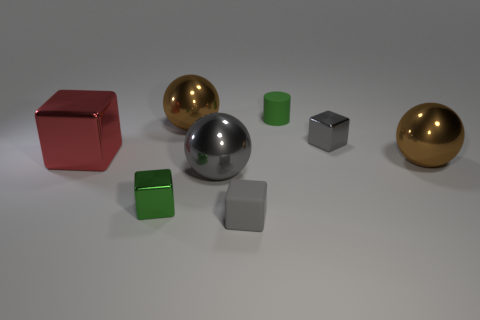There is a small gray object that is to the right of the cylinder behind the gray metal block; how many large spheres are to the right of it?
Your answer should be compact. 1. There is a small metallic thing that is to the left of the green rubber cylinder; what color is it?
Ensure brevity in your answer.  Green. There is a metallic cube right of the small green metallic block; does it have the same color as the small cylinder?
Provide a short and direct response. No. What is the size of the rubber thing that is the same shape as the small green shiny object?
Provide a succinct answer. Small. Is there any other thing that is the same size as the red shiny thing?
Ensure brevity in your answer.  Yes. What is the tiny gray block to the left of the small metallic object that is behind the brown metallic sphere that is to the right of the green cylinder made of?
Your answer should be very brief. Rubber. Are there more large red metal things right of the red thing than red cubes that are on the left side of the gray rubber block?
Your response must be concise. No. Do the red metallic thing and the green metallic cube have the same size?
Provide a succinct answer. No. What is the color of the large object that is the same shape as the small green metal thing?
Make the answer very short. Red. What number of rubber objects have the same color as the tiny cylinder?
Your response must be concise. 0. 